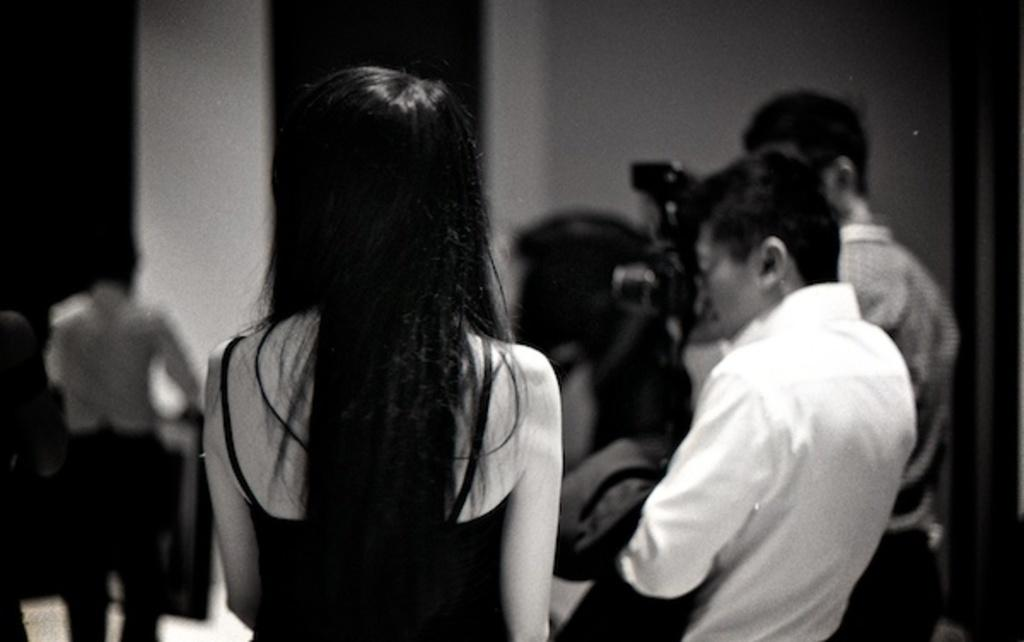What is the color scheme of the image? The image is black and white. What is happening in the middle of the image? There are persons in the middle of the image, and one of them is clicking a picture. Can you describe the gender of one of the persons in the image? Yes, there is a woman in the middle of the image. What type of field can be seen in the background of the image? There is no field visible in the background of the image; it is a black and white image with persons in the middle. What is the time of day depicted in the image? The image is black and white, so it is not possible to determine the time of day based on the color scheme. 